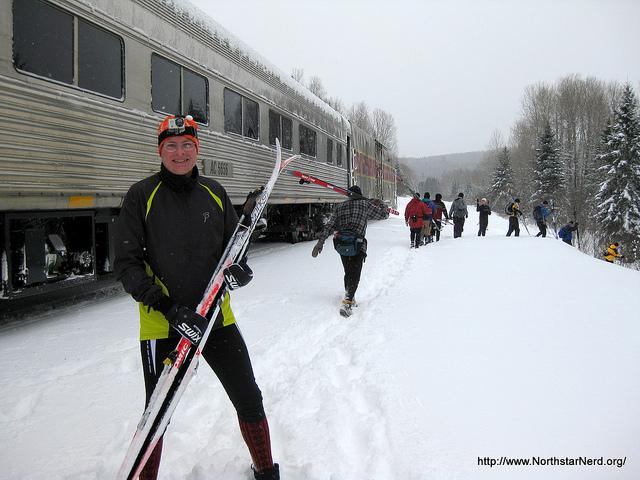How did these skiers get to this location? Please explain your reasoning. train. There is a train parked behind the people. 